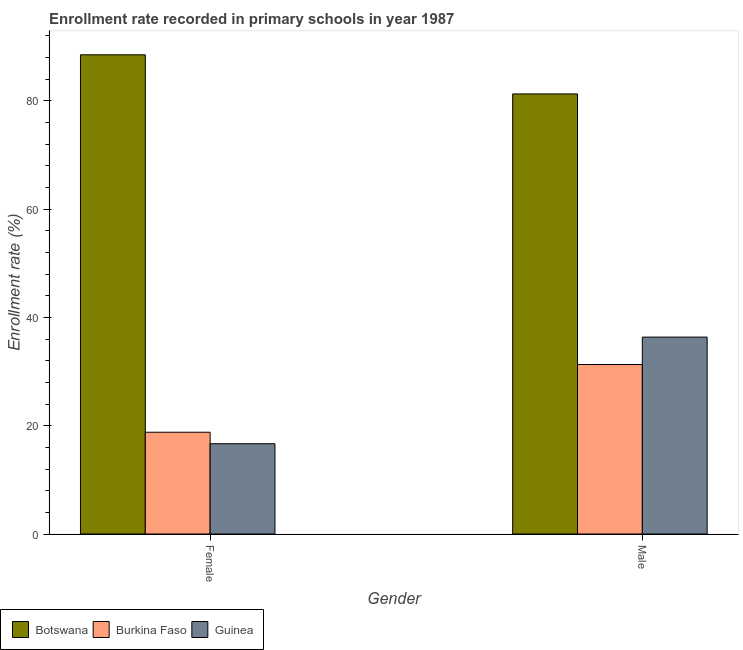How many different coloured bars are there?
Offer a very short reply. 3. How many groups of bars are there?
Offer a terse response. 2. Are the number of bars per tick equal to the number of legend labels?
Your answer should be very brief. Yes. How many bars are there on the 1st tick from the right?
Offer a terse response. 3. What is the enrollment rate of female students in Botswana?
Provide a short and direct response. 88.5. Across all countries, what is the maximum enrollment rate of male students?
Provide a succinct answer. 81.27. Across all countries, what is the minimum enrollment rate of female students?
Provide a short and direct response. 16.67. In which country was the enrollment rate of female students maximum?
Your answer should be very brief. Botswana. In which country was the enrollment rate of female students minimum?
Provide a succinct answer. Guinea. What is the total enrollment rate of male students in the graph?
Your answer should be compact. 148.94. What is the difference between the enrollment rate of female students in Botswana and that in Burkina Faso?
Ensure brevity in your answer.  69.71. What is the difference between the enrollment rate of female students in Burkina Faso and the enrollment rate of male students in Guinea?
Offer a terse response. -17.57. What is the average enrollment rate of male students per country?
Keep it short and to the point. 49.65. What is the difference between the enrollment rate of female students and enrollment rate of male students in Guinea?
Offer a terse response. -19.69. In how many countries, is the enrollment rate of female students greater than 44 %?
Keep it short and to the point. 1. What is the ratio of the enrollment rate of female students in Burkina Faso to that in Guinea?
Keep it short and to the point. 1.13. In how many countries, is the enrollment rate of male students greater than the average enrollment rate of male students taken over all countries?
Ensure brevity in your answer.  1. What does the 1st bar from the left in Female represents?
Keep it short and to the point. Botswana. What does the 3rd bar from the right in Female represents?
Your answer should be very brief. Botswana. Are all the bars in the graph horizontal?
Your answer should be very brief. No. What is the difference between two consecutive major ticks on the Y-axis?
Offer a very short reply. 20. Are the values on the major ticks of Y-axis written in scientific E-notation?
Provide a short and direct response. No. How many legend labels are there?
Offer a terse response. 3. What is the title of the graph?
Give a very brief answer. Enrollment rate recorded in primary schools in year 1987. Does "Mozambique" appear as one of the legend labels in the graph?
Your answer should be very brief. No. What is the label or title of the X-axis?
Your answer should be compact. Gender. What is the label or title of the Y-axis?
Give a very brief answer. Enrollment rate (%). What is the Enrollment rate (%) in Botswana in Female?
Your answer should be compact. 88.5. What is the Enrollment rate (%) of Burkina Faso in Female?
Offer a very short reply. 18.79. What is the Enrollment rate (%) of Guinea in Female?
Your answer should be compact. 16.67. What is the Enrollment rate (%) in Botswana in Male?
Provide a succinct answer. 81.27. What is the Enrollment rate (%) in Burkina Faso in Male?
Give a very brief answer. 31.3. What is the Enrollment rate (%) in Guinea in Male?
Your answer should be compact. 36.36. Across all Gender, what is the maximum Enrollment rate (%) in Botswana?
Give a very brief answer. 88.5. Across all Gender, what is the maximum Enrollment rate (%) of Burkina Faso?
Make the answer very short. 31.3. Across all Gender, what is the maximum Enrollment rate (%) in Guinea?
Keep it short and to the point. 36.36. Across all Gender, what is the minimum Enrollment rate (%) of Botswana?
Offer a very short reply. 81.27. Across all Gender, what is the minimum Enrollment rate (%) of Burkina Faso?
Your response must be concise. 18.79. Across all Gender, what is the minimum Enrollment rate (%) in Guinea?
Provide a succinct answer. 16.67. What is the total Enrollment rate (%) of Botswana in the graph?
Keep it short and to the point. 169.77. What is the total Enrollment rate (%) of Burkina Faso in the graph?
Give a very brief answer. 50.1. What is the total Enrollment rate (%) in Guinea in the graph?
Ensure brevity in your answer.  53.03. What is the difference between the Enrollment rate (%) in Botswana in Female and that in Male?
Your answer should be compact. 7.23. What is the difference between the Enrollment rate (%) in Burkina Faso in Female and that in Male?
Provide a short and direct response. -12.51. What is the difference between the Enrollment rate (%) of Guinea in Female and that in Male?
Keep it short and to the point. -19.69. What is the difference between the Enrollment rate (%) in Botswana in Female and the Enrollment rate (%) in Burkina Faso in Male?
Your answer should be very brief. 57.2. What is the difference between the Enrollment rate (%) of Botswana in Female and the Enrollment rate (%) of Guinea in Male?
Provide a succinct answer. 52.14. What is the difference between the Enrollment rate (%) of Burkina Faso in Female and the Enrollment rate (%) of Guinea in Male?
Your response must be concise. -17.57. What is the average Enrollment rate (%) in Botswana per Gender?
Your response must be concise. 84.89. What is the average Enrollment rate (%) of Burkina Faso per Gender?
Your response must be concise. 25.05. What is the average Enrollment rate (%) in Guinea per Gender?
Your answer should be very brief. 26.52. What is the difference between the Enrollment rate (%) of Botswana and Enrollment rate (%) of Burkina Faso in Female?
Offer a terse response. 69.71. What is the difference between the Enrollment rate (%) of Botswana and Enrollment rate (%) of Guinea in Female?
Your answer should be compact. 71.83. What is the difference between the Enrollment rate (%) in Burkina Faso and Enrollment rate (%) in Guinea in Female?
Provide a short and direct response. 2.12. What is the difference between the Enrollment rate (%) in Botswana and Enrollment rate (%) in Burkina Faso in Male?
Ensure brevity in your answer.  49.97. What is the difference between the Enrollment rate (%) of Botswana and Enrollment rate (%) of Guinea in Male?
Your response must be concise. 44.91. What is the difference between the Enrollment rate (%) in Burkina Faso and Enrollment rate (%) in Guinea in Male?
Your answer should be compact. -5.06. What is the ratio of the Enrollment rate (%) in Botswana in Female to that in Male?
Your answer should be compact. 1.09. What is the ratio of the Enrollment rate (%) in Burkina Faso in Female to that in Male?
Provide a succinct answer. 0.6. What is the ratio of the Enrollment rate (%) of Guinea in Female to that in Male?
Give a very brief answer. 0.46. What is the difference between the highest and the second highest Enrollment rate (%) of Botswana?
Give a very brief answer. 7.23. What is the difference between the highest and the second highest Enrollment rate (%) of Burkina Faso?
Your answer should be compact. 12.51. What is the difference between the highest and the second highest Enrollment rate (%) of Guinea?
Provide a succinct answer. 19.69. What is the difference between the highest and the lowest Enrollment rate (%) of Botswana?
Give a very brief answer. 7.23. What is the difference between the highest and the lowest Enrollment rate (%) of Burkina Faso?
Your answer should be compact. 12.51. What is the difference between the highest and the lowest Enrollment rate (%) of Guinea?
Provide a succinct answer. 19.69. 